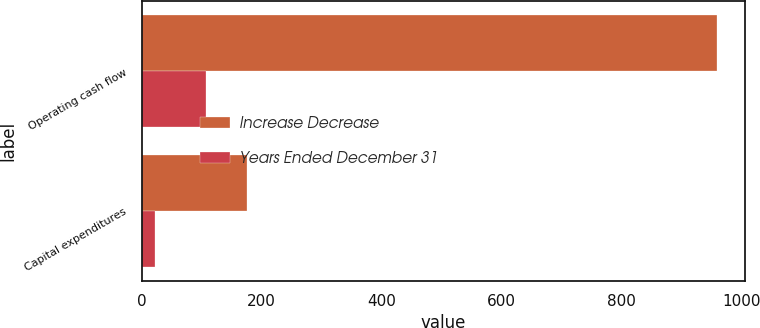Convert chart. <chart><loc_0><loc_0><loc_500><loc_500><stacked_bar_chart><ecel><fcel>Operating cash flow<fcel>Capital expenditures<nl><fcel>Increase Decrease<fcel>958<fcel>175<nl><fcel>Years Ended December 31<fcel>108<fcel>23<nl></chart> 